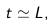<formula> <loc_0><loc_0><loc_500><loc_500>t \simeq L ,</formula> 